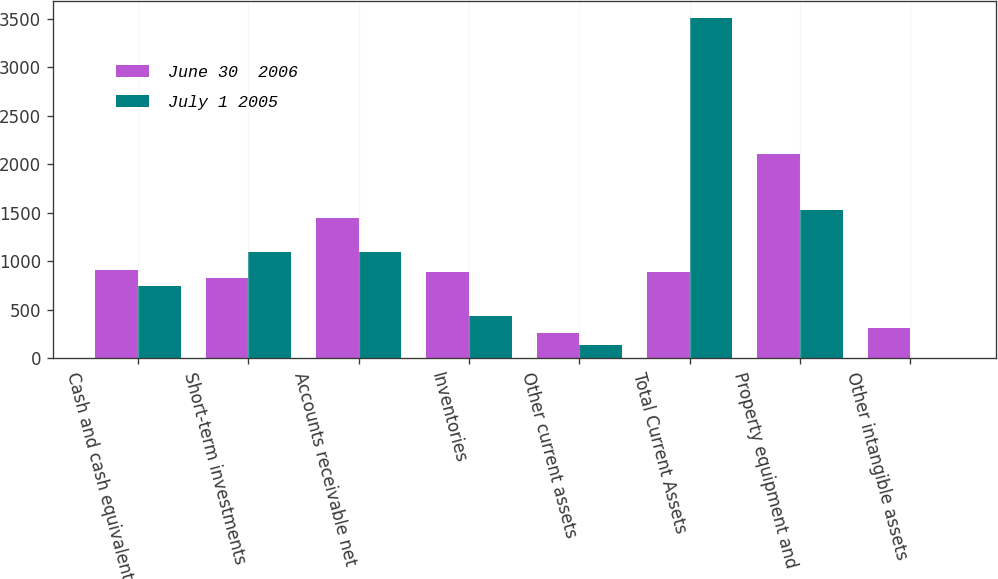Convert chart to OTSL. <chart><loc_0><loc_0><loc_500><loc_500><stacked_bar_chart><ecel><fcel>Cash and cash equivalents<fcel>Short-term investments<fcel>Accounts receivable net<fcel>Inventories<fcel>Other current assets<fcel>Total Current Assets<fcel>Property equipment and<fcel>Other intangible assets<nl><fcel>June 30  2006<fcel>910<fcel>823<fcel>1445<fcel>891<fcel>264<fcel>891<fcel>2106<fcel>307<nl><fcel>July 1 2005<fcel>746<fcel>1090<fcel>1094<fcel>431<fcel>141<fcel>3502<fcel>1529<fcel>3<nl></chart> 